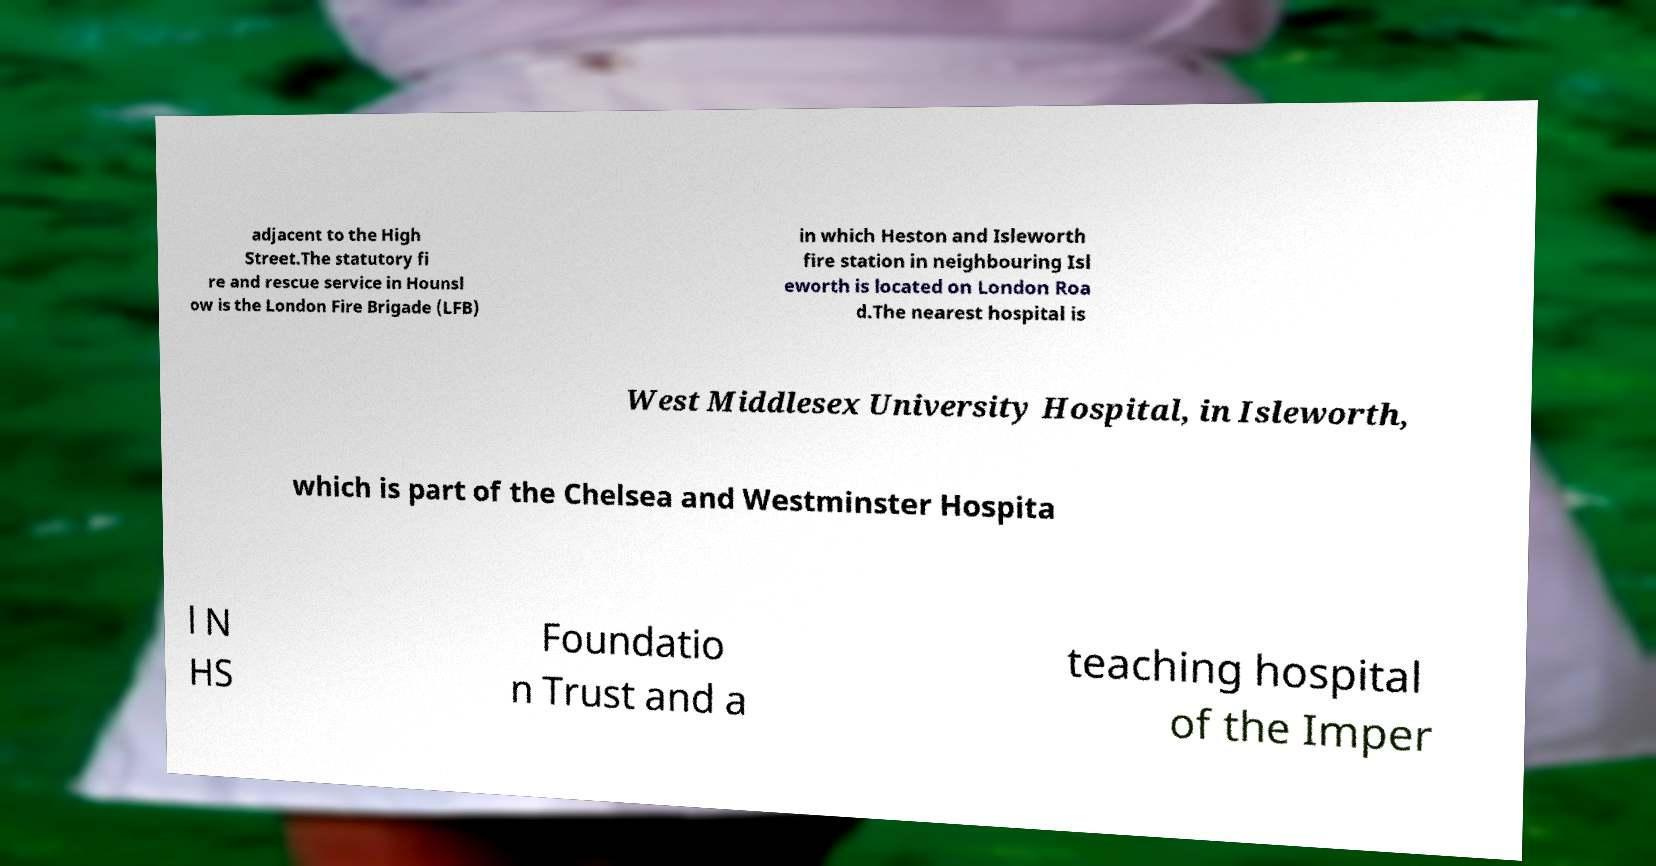For documentation purposes, I need the text within this image transcribed. Could you provide that? adjacent to the High Street.The statutory fi re and rescue service in Hounsl ow is the London Fire Brigade (LFB) in which Heston and Isleworth fire station in neighbouring Isl eworth is located on London Roa d.The nearest hospital is West Middlesex University Hospital, in Isleworth, which is part of the Chelsea and Westminster Hospita l N HS Foundatio n Trust and a teaching hospital of the Imper 